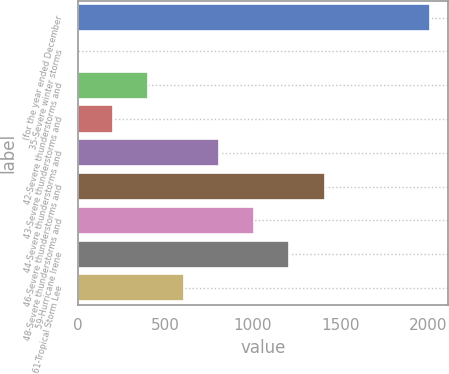Convert chart to OTSL. <chart><loc_0><loc_0><loc_500><loc_500><bar_chart><fcel>(for the year ended December<fcel>35-Severe winter storms<fcel>42-Severe thunderstorms and<fcel>43-Severe thunderstorms and<fcel>44-Severe thunderstorms and<fcel>46-Severe thunderstorms and<fcel>48-Severe thunderstorms and<fcel>59-Hurricane Irene<fcel>61-Tropical Storm Lee<nl><fcel>2012<fcel>1<fcel>403.2<fcel>202.1<fcel>805.4<fcel>1408.7<fcel>1006.5<fcel>1207.6<fcel>604.3<nl></chart> 